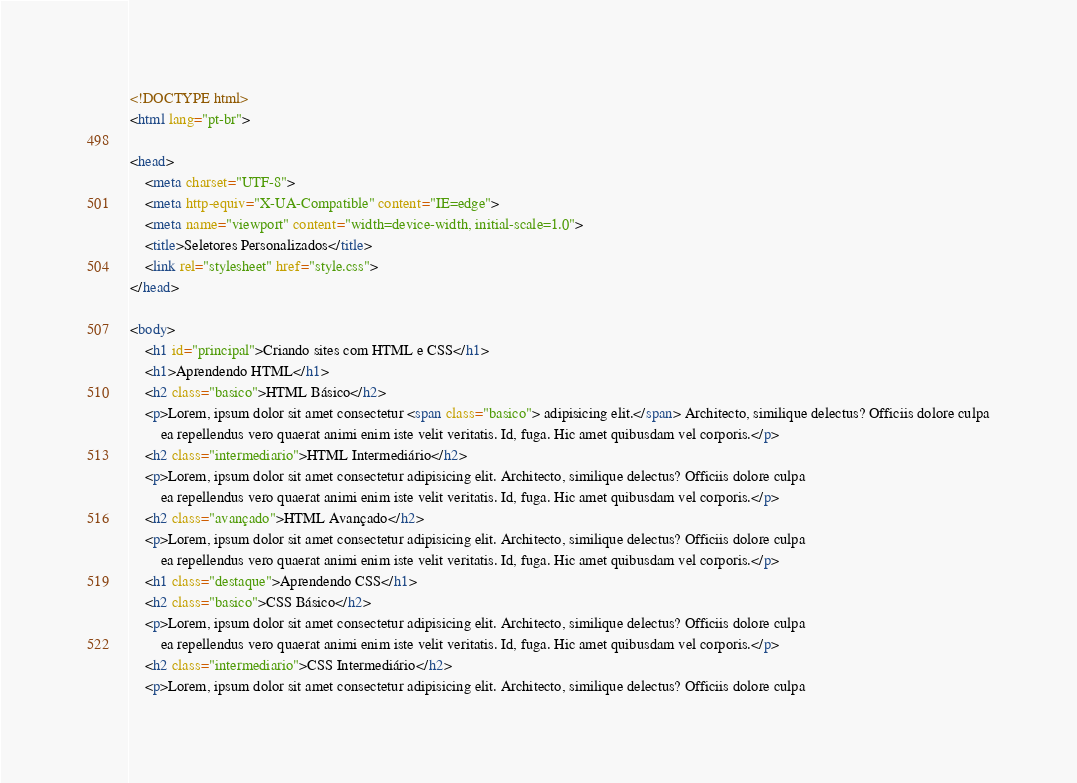Convert code to text. <code><loc_0><loc_0><loc_500><loc_500><_HTML_><!DOCTYPE html>
<html lang="pt-br">

<head>
    <meta charset="UTF-8">
    <meta http-equiv="X-UA-Compatible" content="IE=edge">
    <meta name="viewport" content="width=device-width, initial-scale=1.0">
    <title>Seletores Personalizados</title>
    <link rel="stylesheet" href="style.css">
</head>

<body>
    <h1 id="principal">Criando sites com HTML e CSS</h1>
    <h1>Aprendendo HTML</h1>
    <h2 class="basico">HTML Básico</h2>
    <p>Lorem, ipsum dolor sit amet consectetur <span class="basico"> adipisicing elit.</span> Architecto, similique delectus? Officiis dolore culpa
        ea repellendus vero quaerat animi enim iste velit veritatis. Id, fuga. Hic amet quibusdam vel corporis.</p>
    <h2 class="intermediario">HTML Intermediário</h2>
    <p>Lorem, ipsum dolor sit amet consectetur adipisicing elit. Architecto, similique delectus? Officiis dolore culpa
        ea repellendus vero quaerat animi enim iste velit veritatis. Id, fuga. Hic amet quibusdam vel corporis.</p>
    <h2 class="avançado">HTML Avançado</h2>
    <p>Lorem, ipsum dolor sit amet consectetur adipisicing elit. Architecto, similique delectus? Officiis dolore culpa
        ea repellendus vero quaerat animi enim iste velit veritatis. Id, fuga. Hic amet quibusdam vel corporis.</p>
    <h1 class="destaque">Aprendendo CSS</h1>
    <h2 class="basico">CSS Básico</h2>
    <p>Lorem, ipsum dolor sit amet consectetur adipisicing elit. Architecto, similique delectus? Officiis dolore culpa
        ea repellendus vero quaerat animi enim iste velit veritatis. Id, fuga. Hic amet quibusdam vel corporis.</p>
    <h2 class="intermediario">CSS Intermediário</h2>
    <p>Lorem, ipsum dolor sit amet consectetur adipisicing elit. Architecto, similique delectus? Officiis dolore culpa</code> 